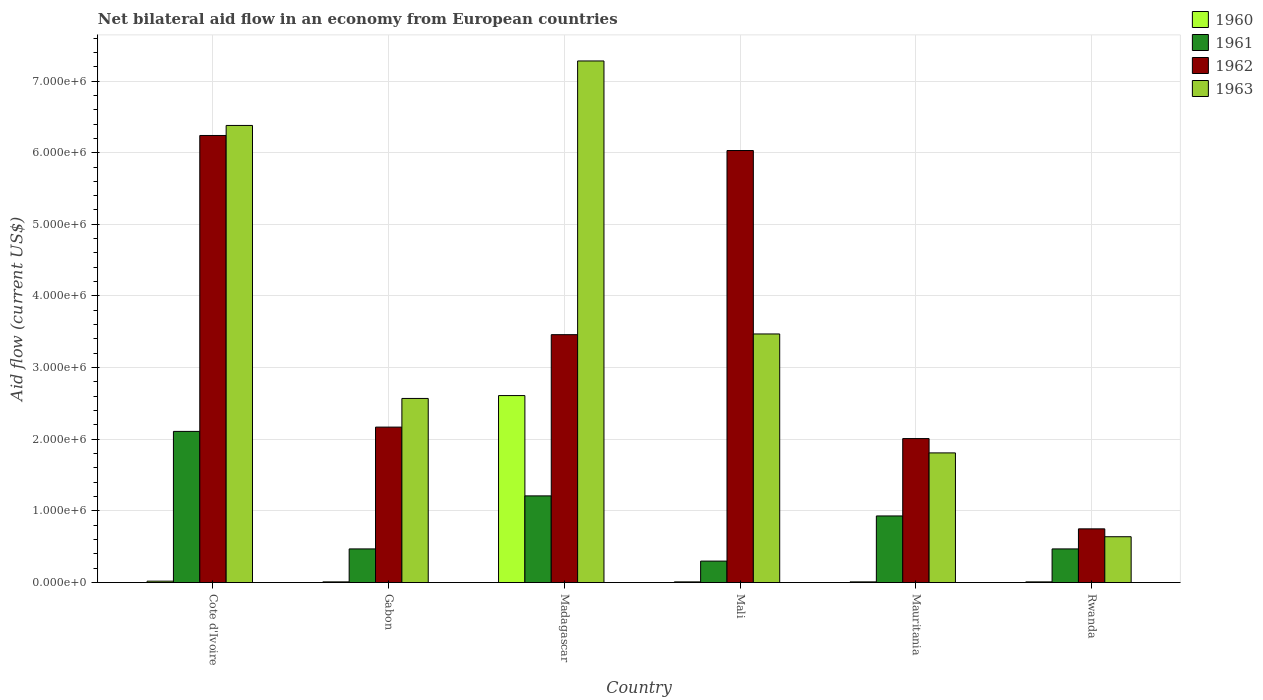How many different coloured bars are there?
Give a very brief answer. 4. Are the number of bars on each tick of the X-axis equal?
Provide a short and direct response. Yes. How many bars are there on the 4th tick from the left?
Provide a succinct answer. 4. How many bars are there on the 5th tick from the right?
Make the answer very short. 4. What is the label of the 2nd group of bars from the left?
Provide a succinct answer. Gabon. What is the net bilateral aid flow in 1960 in Rwanda?
Your answer should be compact. 10000. Across all countries, what is the maximum net bilateral aid flow in 1962?
Keep it short and to the point. 6.24e+06. Across all countries, what is the minimum net bilateral aid flow in 1963?
Your answer should be very brief. 6.40e+05. In which country was the net bilateral aid flow in 1963 maximum?
Give a very brief answer. Madagascar. In which country was the net bilateral aid flow in 1962 minimum?
Make the answer very short. Rwanda. What is the total net bilateral aid flow in 1960 in the graph?
Your answer should be compact. 2.67e+06. What is the difference between the net bilateral aid flow in 1962 in Cote d'Ivoire and that in Mauritania?
Ensure brevity in your answer.  4.23e+06. What is the difference between the net bilateral aid flow in 1963 in Madagascar and the net bilateral aid flow in 1962 in Cote d'Ivoire?
Keep it short and to the point. 1.04e+06. What is the average net bilateral aid flow in 1961 per country?
Your response must be concise. 9.15e+05. What is the difference between the net bilateral aid flow of/in 1961 and net bilateral aid flow of/in 1963 in Gabon?
Your response must be concise. -2.10e+06. What is the difference between the highest and the second highest net bilateral aid flow in 1963?
Provide a short and direct response. 3.81e+06. What is the difference between the highest and the lowest net bilateral aid flow in 1961?
Your answer should be compact. 1.81e+06. What does the 1st bar from the left in Rwanda represents?
Keep it short and to the point. 1960. Is it the case that in every country, the sum of the net bilateral aid flow in 1960 and net bilateral aid flow in 1963 is greater than the net bilateral aid flow in 1962?
Your response must be concise. No. How many bars are there?
Your response must be concise. 24. How many countries are there in the graph?
Provide a succinct answer. 6. What is the difference between two consecutive major ticks on the Y-axis?
Ensure brevity in your answer.  1.00e+06. Does the graph contain any zero values?
Provide a succinct answer. No. Does the graph contain grids?
Keep it short and to the point. Yes. How many legend labels are there?
Your response must be concise. 4. What is the title of the graph?
Make the answer very short. Net bilateral aid flow in an economy from European countries. What is the label or title of the X-axis?
Your answer should be compact. Country. What is the label or title of the Y-axis?
Offer a very short reply. Aid flow (current US$). What is the Aid flow (current US$) of 1960 in Cote d'Ivoire?
Provide a short and direct response. 2.00e+04. What is the Aid flow (current US$) in 1961 in Cote d'Ivoire?
Your answer should be compact. 2.11e+06. What is the Aid flow (current US$) of 1962 in Cote d'Ivoire?
Your answer should be compact. 6.24e+06. What is the Aid flow (current US$) in 1963 in Cote d'Ivoire?
Give a very brief answer. 6.38e+06. What is the Aid flow (current US$) in 1962 in Gabon?
Your answer should be very brief. 2.17e+06. What is the Aid flow (current US$) of 1963 in Gabon?
Make the answer very short. 2.57e+06. What is the Aid flow (current US$) in 1960 in Madagascar?
Offer a very short reply. 2.61e+06. What is the Aid flow (current US$) in 1961 in Madagascar?
Your answer should be compact. 1.21e+06. What is the Aid flow (current US$) of 1962 in Madagascar?
Make the answer very short. 3.46e+06. What is the Aid flow (current US$) of 1963 in Madagascar?
Provide a succinct answer. 7.28e+06. What is the Aid flow (current US$) of 1962 in Mali?
Keep it short and to the point. 6.03e+06. What is the Aid flow (current US$) in 1963 in Mali?
Provide a succinct answer. 3.47e+06. What is the Aid flow (current US$) in 1961 in Mauritania?
Your answer should be compact. 9.30e+05. What is the Aid flow (current US$) of 1962 in Mauritania?
Your answer should be compact. 2.01e+06. What is the Aid flow (current US$) in 1963 in Mauritania?
Offer a terse response. 1.81e+06. What is the Aid flow (current US$) in 1960 in Rwanda?
Your answer should be very brief. 10000. What is the Aid flow (current US$) of 1962 in Rwanda?
Your answer should be very brief. 7.50e+05. What is the Aid flow (current US$) of 1963 in Rwanda?
Your answer should be very brief. 6.40e+05. Across all countries, what is the maximum Aid flow (current US$) of 1960?
Provide a short and direct response. 2.61e+06. Across all countries, what is the maximum Aid flow (current US$) in 1961?
Ensure brevity in your answer.  2.11e+06. Across all countries, what is the maximum Aid flow (current US$) of 1962?
Your response must be concise. 6.24e+06. Across all countries, what is the maximum Aid flow (current US$) of 1963?
Your response must be concise. 7.28e+06. Across all countries, what is the minimum Aid flow (current US$) in 1960?
Offer a terse response. 10000. Across all countries, what is the minimum Aid flow (current US$) in 1961?
Give a very brief answer. 3.00e+05. Across all countries, what is the minimum Aid flow (current US$) of 1962?
Make the answer very short. 7.50e+05. Across all countries, what is the minimum Aid flow (current US$) of 1963?
Your response must be concise. 6.40e+05. What is the total Aid flow (current US$) of 1960 in the graph?
Your answer should be very brief. 2.67e+06. What is the total Aid flow (current US$) of 1961 in the graph?
Your answer should be very brief. 5.49e+06. What is the total Aid flow (current US$) in 1962 in the graph?
Keep it short and to the point. 2.07e+07. What is the total Aid flow (current US$) of 1963 in the graph?
Provide a succinct answer. 2.22e+07. What is the difference between the Aid flow (current US$) in 1961 in Cote d'Ivoire and that in Gabon?
Give a very brief answer. 1.64e+06. What is the difference between the Aid flow (current US$) in 1962 in Cote d'Ivoire and that in Gabon?
Provide a short and direct response. 4.07e+06. What is the difference between the Aid flow (current US$) of 1963 in Cote d'Ivoire and that in Gabon?
Offer a terse response. 3.81e+06. What is the difference between the Aid flow (current US$) of 1960 in Cote d'Ivoire and that in Madagascar?
Give a very brief answer. -2.59e+06. What is the difference between the Aid flow (current US$) in 1962 in Cote d'Ivoire and that in Madagascar?
Provide a short and direct response. 2.78e+06. What is the difference between the Aid flow (current US$) in 1963 in Cote d'Ivoire and that in Madagascar?
Keep it short and to the point. -9.00e+05. What is the difference between the Aid flow (current US$) of 1961 in Cote d'Ivoire and that in Mali?
Your answer should be very brief. 1.81e+06. What is the difference between the Aid flow (current US$) in 1962 in Cote d'Ivoire and that in Mali?
Keep it short and to the point. 2.10e+05. What is the difference between the Aid flow (current US$) in 1963 in Cote d'Ivoire and that in Mali?
Keep it short and to the point. 2.91e+06. What is the difference between the Aid flow (current US$) of 1960 in Cote d'Ivoire and that in Mauritania?
Ensure brevity in your answer.  10000. What is the difference between the Aid flow (current US$) of 1961 in Cote d'Ivoire and that in Mauritania?
Give a very brief answer. 1.18e+06. What is the difference between the Aid flow (current US$) in 1962 in Cote d'Ivoire and that in Mauritania?
Provide a succinct answer. 4.23e+06. What is the difference between the Aid flow (current US$) in 1963 in Cote d'Ivoire and that in Mauritania?
Make the answer very short. 4.57e+06. What is the difference between the Aid flow (current US$) in 1961 in Cote d'Ivoire and that in Rwanda?
Offer a very short reply. 1.64e+06. What is the difference between the Aid flow (current US$) in 1962 in Cote d'Ivoire and that in Rwanda?
Your answer should be compact. 5.49e+06. What is the difference between the Aid flow (current US$) of 1963 in Cote d'Ivoire and that in Rwanda?
Provide a succinct answer. 5.74e+06. What is the difference between the Aid flow (current US$) in 1960 in Gabon and that in Madagascar?
Your response must be concise. -2.60e+06. What is the difference between the Aid flow (current US$) in 1961 in Gabon and that in Madagascar?
Offer a very short reply. -7.40e+05. What is the difference between the Aid flow (current US$) of 1962 in Gabon and that in Madagascar?
Give a very brief answer. -1.29e+06. What is the difference between the Aid flow (current US$) of 1963 in Gabon and that in Madagascar?
Your response must be concise. -4.71e+06. What is the difference between the Aid flow (current US$) in 1960 in Gabon and that in Mali?
Offer a terse response. 0. What is the difference between the Aid flow (current US$) in 1961 in Gabon and that in Mali?
Your answer should be very brief. 1.70e+05. What is the difference between the Aid flow (current US$) of 1962 in Gabon and that in Mali?
Provide a short and direct response. -3.86e+06. What is the difference between the Aid flow (current US$) in 1963 in Gabon and that in Mali?
Make the answer very short. -9.00e+05. What is the difference between the Aid flow (current US$) of 1961 in Gabon and that in Mauritania?
Ensure brevity in your answer.  -4.60e+05. What is the difference between the Aid flow (current US$) in 1962 in Gabon and that in Mauritania?
Provide a succinct answer. 1.60e+05. What is the difference between the Aid flow (current US$) of 1963 in Gabon and that in Mauritania?
Your answer should be compact. 7.60e+05. What is the difference between the Aid flow (current US$) in 1962 in Gabon and that in Rwanda?
Your answer should be compact. 1.42e+06. What is the difference between the Aid flow (current US$) of 1963 in Gabon and that in Rwanda?
Give a very brief answer. 1.93e+06. What is the difference between the Aid flow (current US$) in 1960 in Madagascar and that in Mali?
Your answer should be compact. 2.60e+06. What is the difference between the Aid flow (current US$) of 1961 in Madagascar and that in Mali?
Give a very brief answer. 9.10e+05. What is the difference between the Aid flow (current US$) of 1962 in Madagascar and that in Mali?
Your response must be concise. -2.57e+06. What is the difference between the Aid flow (current US$) of 1963 in Madagascar and that in Mali?
Keep it short and to the point. 3.81e+06. What is the difference between the Aid flow (current US$) in 1960 in Madagascar and that in Mauritania?
Offer a very short reply. 2.60e+06. What is the difference between the Aid flow (current US$) in 1961 in Madagascar and that in Mauritania?
Your answer should be very brief. 2.80e+05. What is the difference between the Aid flow (current US$) of 1962 in Madagascar and that in Mauritania?
Offer a very short reply. 1.45e+06. What is the difference between the Aid flow (current US$) in 1963 in Madagascar and that in Mauritania?
Offer a very short reply. 5.47e+06. What is the difference between the Aid flow (current US$) of 1960 in Madagascar and that in Rwanda?
Make the answer very short. 2.60e+06. What is the difference between the Aid flow (current US$) in 1961 in Madagascar and that in Rwanda?
Offer a terse response. 7.40e+05. What is the difference between the Aid flow (current US$) of 1962 in Madagascar and that in Rwanda?
Your response must be concise. 2.71e+06. What is the difference between the Aid flow (current US$) in 1963 in Madagascar and that in Rwanda?
Keep it short and to the point. 6.64e+06. What is the difference between the Aid flow (current US$) of 1960 in Mali and that in Mauritania?
Keep it short and to the point. 0. What is the difference between the Aid flow (current US$) of 1961 in Mali and that in Mauritania?
Offer a terse response. -6.30e+05. What is the difference between the Aid flow (current US$) of 1962 in Mali and that in Mauritania?
Offer a terse response. 4.02e+06. What is the difference between the Aid flow (current US$) of 1963 in Mali and that in Mauritania?
Offer a very short reply. 1.66e+06. What is the difference between the Aid flow (current US$) in 1960 in Mali and that in Rwanda?
Ensure brevity in your answer.  0. What is the difference between the Aid flow (current US$) of 1962 in Mali and that in Rwanda?
Offer a terse response. 5.28e+06. What is the difference between the Aid flow (current US$) of 1963 in Mali and that in Rwanda?
Ensure brevity in your answer.  2.83e+06. What is the difference between the Aid flow (current US$) in 1960 in Mauritania and that in Rwanda?
Your answer should be very brief. 0. What is the difference between the Aid flow (current US$) of 1961 in Mauritania and that in Rwanda?
Give a very brief answer. 4.60e+05. What is the difference between the Aid flow (current US$) in 1962 in Mauritania and that in Rwanda?
Make the answer very short. 1.26e+06. What is the difference between the Aid flow (current US$) of 1963 in Mauritania and that in Rwanda?
Provide a short and direct response. 1.17e+06. What is the difference between the Aid flow (current US$) of 1960 in Cote d'Ivoire and the Aid flow (current US$) of 1961 in Gabon?
Your answer should be compact. -4.50e+05. What is the difference between the Aid flow (current US$) in 1960 in Cote d'Ivoire and the Aid flow (current US$) in 1962 in Gabon?
Offer a terse response. -2.15e+06. What is the difference between the Aid flow (current US$) of 1960 in Cote d'Ivoire and the Aid flow (current US$) of 1963 in Gabon?
Provide a succinct answer. -2.55e+06. What is the difference between the Aid flow (current US$) in 1961 in Cote d'Ivoire and the Aid flow (current US$) in 1962 in Gabon?
Offer a terse response. -6.00e+04. What is the difference between the Aid flow (current US$) of 1961 in Cote d'Ivoire and the Aid flow (current US$) of 1963 in Gabon?
Provide a succinct answer. -4.60e+05. What is the difference between the Aid flow (current US$) in 1962 in Cote d'Ivoire and the Aid flow (current US$) in 1963 in Gabon?
Your response must be concise. 3.67e+06. What is the difference between the Aid flow (current US$) of 1960 in Cote d'Ivoire and the Aid flow (current US$) of 1961 in Madagascar?
Provide a short and direct response. -1.19e+06. What is the difference between the Aid flow (current US$) of 1960 in Cote d'Ivoire and the Aid flow (current US$) of 1962 in Madagascar?
Provide a short and direct response. -3.44e+06. What is the difference between the Aid flow (current US$) of 1960 in Cote d'Ivoire and the Aid flow (current US$) of 1963 in Madagascar?
Offer a terse response. -7.26e+06. What is the difference between the Aid flow (current US$) of 1961 in Cote d'Ivoire and the Aid flow (current US$) of 1962 in Madagascar?
Offer a terse response. -1.35e+06. What is the difference between the Aid flow (current US$) in 1961 in Cote d'Ivoire and the Aid flow (current US$) in 1963 in Madagascar?
Provide a succinct answer. -5.17e+06. What is the difference between the Aid flow (current US$) in 1962 in Cote d'Ivoire and the Aid flow (current US$) in 1963 in Madagascar?
Offer a terse response. -1.04e+06. What is the difference between the Aid flow (current US$) of 1960 in Cote d'Ivoire and the Aid flow (current US$) of 1961 in Mali?
Offer a very short reply. -2.80e+05. What is the difference between the Aid flow (current US$) of 1960 in Cote d'Ivoire and the Aid flow (current US$) of 1962 in Mali?
Your response must be concise. -6.01e+06. What is the difference between the Aid flow (current US$) in 1960 in Cote d'Ivoire and the Aid flow (current US$) in 1963 in Mali?
Provide a succinct answer. -3.45e+06. What is the difference between the Aid flow (current US$) in 1961 in Cote d'Ivoire and the Aid flow (current US$) in 1962 in Mali?
Keep it short and to the point. -3.92e+06. What is the difference between the Aid flow (current US$) of 1961 in Cote d'Ivoire and the Aid flow (current US$) of 1963 in Mali?
Keep it short and to the point. -1.36e+06. What is the difference between the Aid flow (current US$) of 1962 in Cote d'Ivoire and the Aid flow (current US$) of 1963 in Mali?
Keep it short and to the point. 2.77e+06. What is the difference between the Aid flow (current US$) of 1960 in Cote d'Ivoire and the Aid flow (current US$) of 1961 in Mauritania?
Provide a succinct answer. -9.10e+05. What is the difference between the Aid flow (current US$) in 1960 in Cote d'Ivoire and the Aid flow (current US$) in 1962 in Mauritania?
Make the answer very short. -1.99e+06. What is the difference between the Aid flow (current US$) of 1960 in Cote d'Ivoire and the Aid flow (current US$) of 1963 in Mauritania?
Offer a very short reply. -1.79e+06. What is the difference between the Aid flow (current US$) of 1961 in Cote d'Ivoire and the Aid flow (current US$) of 1962 in Mauritania?
Ensure brevity in your answer.  1.00e+05. What is the difference between the Aid flow (current US$) in 1961 in Cote d'Ivoire and the Aid flow (current US$) in 1963 in Mauritania?
Make the answer very short. 3.00e+05. What is the difference between the Aid flow (current US$) in 1962 in Cote d'Ivoire and the Aid flow (current US$) in 1963 in Mauritania?
Offer a very short reply. 4.43e+06. What is the difference between the Aid flow (current US$) of 1960 in Cote d'Ivoire and the Aid flow (current US$) of 1961 in Rwanda?
Provide a short and direct response. -4.50e+05. What is the difference between the Aid flow (current US$) of 1960 in Cote d'Ivoire and the Aid flow (current US$) of 1962 in Rwanda?
Your answer should be very brief. -7.30e+05. What is the difference between the Aid flow (current US$) in 1960 in Cote d'Ivoire and the Aid flow (current US$) in 1963 in Rwanda?
Provide a succinct answer. -6.20e+05. What is the difference between the Aid flow (current US$) of 1961 in Cote d'Ivoire and the Aid flow (current US$) of 1962 in Rwanda?
Offer a terse response. 1.36e+06. What is the difference between the Aid flow (current US$) of 1961 in Cote d'Ivoire and the Aid flow (current US$) of 1963 in Rwanda?
Give a very brief answer. 1.47e+06. What is the difference between the Aid flow (current US$) of 1962 in Cote d'Ivoire and the Aid flow (current US$) of 1963 in Rwanda?
Offer a terse response. 5.60e+06. What is the difference between the Aid flow (current US$) of 1960 in Gabon and the Aid flow (current US$) of 1961 in Madagascar?
Your response must be concise. -1.20e+06. What is the difference between the Aid flow (current US$) in 1960 in Gabon and the Aid flow (current US$) in 1962 in Madagascar?
Keep it short and to the point. -3.45e+06. What is the difference between the Aid flow (current US$) in 1960 in Gabon and the Aid flow (current US$) in 1963 in Madagascar?
Ensure brevity in your answer.  -7.27e+06. What is the difference between the Aid flow (current US$) in 1961 in Gabon and the Aid flow (current US$) in 1962 in Madagascar?
Offer a very short reply. -2.99e+06. What is the difference between the Aid flow (current US$) in 1961 in Gabon and the Aid flow (current US$) in 1963 in Madagascar?
Offer a terse response. -6.81e+06. What is the difference between the Aid flow (current US$) in 1962 in Gabon and the Aid flow (current US$) in 1963 in Madagascar?
Your response must be concise. -5.11e+06. What is the difference between the Aid flow (current US$) in 1960 in Gabon and the Aid flow (current US$) in 1961 in Mali?
Offer a terse response. -2.90e+05. What is the difference between the Aid flow (current US$) of 1960 in Gabon and the Aid flow (current US$) of 1962 in Mali?
Your answer should be compact. -6.02e+06. What is the difference between the Aid flow (current US$) in 1960 in Gabon and the Aid flow (current US$) in 1963 in Mali?
Provide a succinct answer. -3.46e+06. What is the difference between the Aid flow (current US$) of 1961 in Gabon and the Aid flow (current US$) of 1962 in Mali?
Your answer should be very brief. -5.56e+06. What is the difference between the Aid flow (current US$) in 1962 in Gabon and the Aid flow (current US$) in 1963 in Mali?
Give a very brief answer. -1.30e+06. What is the difference between the Aid flow (current US$) in 1960 in Gabon and the Aid flow (current US$) in 1961 in Mauritania?
Provide a short and direct response. -9.20e+05. What is the difference between the Aid flow (current US$) in 1960 in Gabon and the Aid flow (current US$) in 1962 in Mauritania?
Keep it short and to the point. -2.00e+06. What is the difference between the Aid flow (current US$) of 1960 in Gabon and the Aid flow (current US$) of 1963 in Mauritania?
Your response must be concise. -1.80e+06. What is the difference between the Aid flow (current US$) of 1961 in Gabon and the Aid flow (current US$) of 1962 in Mauritania?
Ensure brevity in your answer.  -1.54e+06. What is the difference between the Aid flow (current US$) in 1961 in Gabon and the Aid flow (current US$) in 1963 in Mauritania?
Offer a terse response. -1.34e+06. What is the difference between the Aid flow (current US$) of 1962 in Gabon and the Aid flow (current US$) of 1963 in Mauritania?
Your response must be concise. 3.60e+05. What is the difference between the Aid flow (current US$) of 1960 in Gabon and the Aid flow (current US$) of 1961 in Rwanda?
Keep it short and to the point. -4.60e+05. What is the difference between the Aid flow (current US$) of 1960 in Gabon and the Aid flow (current US$) of 1962 in Rwanda?
Ensure brevity in your answer.  -7.40e+05. What is the difference between the Aid flow (current US$) of 1960 in Gabon and the Aid flow (current US$) of 1963 in Rwanda?
Your response must be concise. -6.30e+05. What is the difference between the Aid flow (current US$) in 1961 in Gabon and the Aid flow (current US$) in 1962 in Rwanda?
Your answer should be compact. -2.80e+05. What is the difference between the Aid flow (current US$) in 1962 in Gabon and the Aid flow (current US$) in 1963 in Rwanda?
Your answer should be compact. 1.53e+06. What is the difference between the Aid flow (current US$) of 1960 in Madagascar and the Aid flow (current US$) of 1961 in Mali?
Ensure brevity in your answer.  2.31e+06. What is the difference between the Aid flow (current US$) in 1960 in Madagascar and the Aid flow (current US$) in 1962 in Mali?
Provide a succinct answer. -3.42e+06. What is the difference between the Aid flow (current US$) of 1960 in Madagascar and the Aid flow (current US$) of 1963 in Mali?
Give a very brief answer. -8.60e+05. What is the difference between the Aid flow (current US$) of 1961 in Madagascar and the Aid flow (current US$) of 1962 in Mali?
Make the answer very short. -4.82e+06. What is the difference between the Aid flow (current US$) in 1961 in Madagascar and the Aid flow (current US$) in 1963 in Mali?
Make the answer very short. -2.26e+06. What is the difference between the Aid flow (current US$) in 1962 in Madagascar and the Aid flow (current US$) in 1963 in Mali?
Your response must be concise. -10000. What is the difference between the Aid flow (current US$) in 1960 in Madagascar and the Aid flow (current US$) in 1961 in Mauritania?
Provide a short and direct response. 1.68e+06. What is the difference between the Aid flow (current US$) in 1961 in Madagascar and the Aid flow (current US$) in 1962 in Mauritania?
Offer a very short reply. -8.00e+05. What is the difference between the Aid flow (current US$) of 1961 in Madagascar and the Aid flow (current US$) of 1963 in Mauritania?
Offer a very short reply. -6.00e+05. What is the difference between the Aid flow (current US$) of 1962 in Madagascar and the Aid flow (current US$) of 1963 in Mauritania?
Make the answer very short. 1.65e+06. What is the difference between the Aid flow (current US$) in 1960 in Madagascar and the Aid flow (current US$) in 1961 in Rwanda?
Provide a succinct answer. 2.14e+06. What is the difference between the Aid flow (current US$) of 1960 in Madagascar and the Aid flow (current US$) of 1962 in Rwanda?
Provide a short and direct response. 1.86e+06. What is the difference between the Aid flow (current US$) of 1960 in Madagascar and the Aid flow (current US$) of 1963 in Rwanda?
Offer a terse response. 1.97e+06. What is the difference between the Aid flow (current US$) of 1961 in Madagascar and the Aid flow (current US$) of 1963 in Rwanda?
Ensure brevity in your answer.  5.70e+05. What is the difference between the Aid flow (current US$) of 1962 in Madagascar and the Aid flow (current US$) of 1963 in Rwanda?
Your answer should be compact. 2.82e+06. What is the difference between the Aid flow (current US$) of 1960 in Mali and the Aid flow (current US$) of 1961 in Mauritania?
Keep it short and to the point. -9.20e+05. What is the difference between the Aid flow (current US$) in 1960 in Mali and the Aid flow (current US$) in 1962 in Mauritania?
Provide a short and direct response. -2.00e+06. What is the difference between the Aid flow (current US$) in 1960 in Mali and the Aid flow (current US$) in 1963 in Mauritania?
Offer a very short reply. -1.80e+06. What is the difference between the Aid flow (current US$) in 1961 in Mali and the Aid flow (current US$) in 1962 in Mauritania?
Provide a short and direct response. -1.71e+06. What is the difference between the Aid flow (current US$) of 1961 in Mali and the Aid flow (current US$) of 1963 in Mauritania?
Provide a short and direct response. -1.51e+06. What is the difference between the Aid flow (current US$) in 1962 in Mali and the Aid flow (current US$) in 1963 in Mauritania?
Offer a terse response. 4.22e+06. What is the difference between the Aid flow (current US$) in 1960 in Mali and the Aid flow (current US$) in 1961 in Rwanda?
Provide a succinct answer. -4.60e+05. What is the difference between the Aid flow (current US$) of 1960 in Mali and the Aid flow (current US$) of 1962 in Rwanda?
Keep it short and to the point. -7.40e+05. What is the difference between the Aid flow (current US$) of 1960 in Mali and the Aid flow (current US$) of 1963 in Rwanda?
Ensure brevity in your answer.  -6.30e+05. What is the difference between the Aid flow (current US$) of 1961 in Mali and the Aid flow (current US$) of 1962 in Rwanda?
Ensure brevity in your answer.  -4.50e+05. What is the difference between the Aid flow (current US$) in 1961 in Mali and the Aid flow (current US$) in 1963 in Rwanda?
Your answer should be very brief. -3.40e+05. What is the difference between the Aid flow (current US$) of 1962 in Mali and the Aid flow (current US$) of 1963 in Rwanda?
Your response must be concise. 5.39e+06. What is the difference between the Aid flow (current US$) in 1960 in Mauritania and the Aid flow (current US$) in 1961 in Rwanda?
Provide a succinct answer. -4.60e+05. What is the difference between the Aid flow (current US$) in 1960 in Mauritania and the Aid flow (current US$) in 1962 in Rwanda?
Keep it short and to the point. -7.40e+05. What is the difference between the Aid flow (current US$) of 1960 in Mauritania and the Aid flow (current US$) of 1963 in Rwanda?
Make the answer very short. -6.30e+05. What is the difference between the Aid flow (current US$) of 1962 in Mauritania and the Aid flow (current US$) of 1963 in Rwanda?
Your answer should be very brief. 1.37e+06. What is the average Aid flow (current US$) of 1960 per country?
Give a very brief answer. 4.45e+05. What is the average Aid flow (current US$) of 1961 per country?
Your answer should be very brief. 9.15e+05. What is the average Aid flow (current US$) in 1962 per country?
Your answer should be very brief. 3.44e+06. What is the average Aid flow (current US$) of 1963 per country?
Your response must be concise. 3.69e+06. What is the difference between the Aid flow (current US$) in 1960 and Aid flow (current US$) in 1961 in Cote d'Ivoire?
Give a very brief answer. -2.09e+06. What is the difference between the Aid flow (current US$) in 1960 and Aid flow (current US$) in 1962 in Cote d'Ivoire?
Keep it short and to the point. -6.22e+06. What is the difference between the Aid flow (current US$) in 1960 and Aid flow (current US$) in 1963 in Cote d'Ivoire?
Your response must be concise. -6.36e+06. What is the difference between the Aid flow (current US$) of 1961 and Aid flow (current US$) of 1962 in Cote d'Ivoire?
Your answer should be compact. -4.13e+06. What is the difference between the Aid flow (current US$) of 1961 and Aid flow (current US$) of 1963 in Cote d'Ivoire?
Provide a short and direct response. -4.27e+06. What is the difference between the Aid flow (current US$) of 1962 and Aid flow (current US$) of 1963 in Cote d'Ivoire?
Offer a very short reply. -1.40e+05. What is the difference between the Aid flow (current US$) of 1960 and Aid flow (current US$) of 1961 in Gabon?
Make the answer very short. -4.60e+05. What is the difference between the Aid flow (current US$) of 1960 and Aid flow (current US$) of 1962 in Gabon?
Provide a succinct answer. -2.16e+06. What is the difference between the Aid flow (current US$) in 1960 and Aid flow (current US$) in 1963 in Gabon?
Ensure brevity in your answer.  -2.56e+06. What is the difference between the Aid flow (current US$) in 1961 and Aid flow (current US$) in 1962 in Gabon?
Keep it short and to the point. -1.70e+06. What is the difference between the Aid flow (current US$) in 1961 and Aid flow (current US$) in 1963 in Gabon?
Your answer should be compact. -2.10e+06. What is the difference between the Aid flow (current US$) in 1962 and Aid flow (current US$) in 1963 in Gabon?
Give a very brief answer. -4.00e+05. What is the difference between the Aid flow (current US$) of 1960 and Aid flow (current US$) of 1961 in Madagascar?
Ensure brevity in your answer.  1.40e+06. What is the difference between the Aid flow (current US$) of 1960 and Aid flow (current US$) of 1962 in Madagascar?
Your response must be concise. -8.50e+05. What is the difference between the Aid flow (current US$) in 1960 and Aid flow (current US$) in 1963 in Madagascar?
Keep it short and to the point. -4.67e+06. What is the difference between the Aid flow (current US$) in 1961 and Aid flow (current US$) in 1962 in Madagascar?
Give a very brief answer. -2.25e+06. What is the difference between the Aid flow (current US$) of 1961 and Aid flow (current US$) of 1963 in Madagascar?
Your answer should be very brief. -6.07e+06. What is the difference between the Aid flow (current US$) in 1962 and Aid flow (current US$) in 1963 in Madagascar?
Make the answer very short. -3.82e+06. What is the difference between the Aid flow (current US$) in 1960 and Aid flow (current US$) in 1962 in Mali?
Your response must be concise. -6.02e+06. What is the difference between the Aid flow (current US$) in 1960 and Aid flow (current US$) in 1963 in Mali?
Provide a short and direct response. -3.46e+06. What is the difference between the Aid flow (current US$) of 1961 and Aid flow (current US$) of 1962 in Mali?
Your answer should be very brief. -5.73e+06. What is the difference between the Aid flow (current US$) in 1961 and Aid flow (current US$) in 1963 in Mali?
Offer a very short reply. -3.17e+06. What is the difference between the Aid flow (current US$) in 1962 and Aid flow (current US$) in 1963 in Mali?
Keep it short and to the point. 2.56e+06. What is the difference between the Aid flow (current US$) in 1960 and Aid flow (current US$) in 1961 in Mauritania?
Your response must be concise. -9.20e+05. What is the difference between the Aid flow (current US$) in 1960 and Aid flow (current US$) in 1963 in Mauritania?
Your answer should be compact. -1.80e+06. What is the difference between the Aid flow (current US$) of 1961 and Aid flow (current US$) of 1962 in Mauritania?
Provide a short and direct response. -1.08e+06. What is the difference between the Aid flow (current US$) of 1961 and Aid flow (current US$) of 1963 in Mauritania?
Keep it short and to the point. -8.80e+05. What is the difference between the Aid flow (current US$) in 1960 and Aid flow (current US$) in 1961 in Rwanda?
Give a very brief answer. -4.60e+05. What is the difference between the Aid flow (current US$) of 1960 and Aid flow (current US$) of 1962 in Rwanda?
Provide a succinct answer. -7.40e+05. What is the difference between the Aid flow (current US$) of 1960 and Aid flow (current US$) of 1963 in Rwanda?
Ensure brevity in your answer.  -6.30e+05. What is the difference between the Aid flow (current US$) of 1961 and Aid flow (current US$) of 1962 in Rwanda?
Your response must be concise. -2.80e+05. What is the difference between the Aid flow (current US$) of 1962 and Aid flow (current US$) of 1963 in Rwanda?
Your answer should be compact. 1.10e+05. What is the ratio of the Aid flow (current US$) of 1960 in Cote d'Ivoire to that in Gabon?
Your response must be concise. 2. What is the ratio of the Aid flow (current US$) of 1961 in Cote d'Ivoire to that in Gabon?
Your answer should be compact. 4.49. What is the ratio of the Aid flow (current US$) in 1962 in Cote d'Ivoire to that in Gabon?
Your response must be concise. 2.88. What is the ratio of the Aid flow (current US$) of 1963 in Cote d'Ivoire to that in Gabon?
Provide a succinct answer. 2.48. What is the ratio of the Aid flow (current US$) in 1960 in Cote d'Ivoire to that in Madagascar?
Your response must be concise. 0.01. What is the ratio of the Aid flow (current US$) in 1961 in Cote d'Ivoire to that in Madagascar?
Provide a short and direct response. 1.74. What is the ratio of the Aid flow (current US$) of 1962 in Cote d'Ivoire to that in Madagascar?
Ensure brevity in your answer.  1.8. What is the ratio of the Aid flow (current US$) of 1963 in Cote d'Ivoire to that in Madagascar?
Your answer should be compact. 0.88. What is the ratio of the Aid flow (current US$) in 1961 in Cote d'Ivoire to that in Mali?
Give a very brief answer. 7.03. What is the ratio of the Aid flow (current US$) of 1962 in Cote d'Ivoire to that in Mali?
Keep it short and to the point. 1.03. What is the ratio of the Aid flow (current US$) of 1963 in Cote d'Ivoire to that in Mali?
Your answer should be very brief. 1.84. What is the ratio of the Aid flow (current US$) in 1961 in Cote d'Ivoire to that in Mauritania?
Keep it short and to the point. 2.27. What is the ratio of the Aid flow (current US$) in 1962 in Cote d'Ivoire to that in Mauritania?
Your response must be concise. 3.1. What is the ratio of the Aid flow (current US$) in 1963 in Cote d'Ivoire to that in Mauritania?
Your answer should be very brief. 3.52. What is the ratio of the Aid flow (current US$) of 1960 in Cote d'Ivoire to that in Rwanda?
Provide a succinct answer. 2. What is the ratio of the Aid flow (current US$) of 1961 in Cote d'Ivoire to that in Rwanda?
Your response must be concise. 4.49. What is the ratio of the Aid flow (current US$) of 1962 in Cote d'Ivoire to that in Rwanda?
Provide a succinct answer. 8.32. What is the ratio of the Aid flow (current US$) in 1963 in Cote d'Ivoire to that in Rwanda?
Your answer should be very brief. 9.97. What is the ratio of the Aid flow (current US$) of 1960 in Gabon to that in Madagascar?
Your response must be concise. 0. What is the ratio of the Aid flow (current US$) of 1961 in Gabon to that in Madagascar?
Provide a succinct answer. 0.39. What is the ratio of the Aid flow (current US$) of 1962 in Gabon to that in Madagascar?
Provide a succinct answer. 0.63. What is the ratio of the Aid flow (current US$) of 1963 in Gabon to that in Madagascar?
Offer a very short reply. 0.35. What is the ratio of the Aid flow (current US$) of 1961 in Gabon to that in Mali?
Your answer should be compact. 1.57. What is the ratio of the Aid flow (current US$) in 1962 in Gabon to that in Mali?
Provide a short and direct response. 0.36. What is the ratio of the Aid flow (current US$) in 1963 in Gabon to that in Mali?
Provide a succinct answer. 0.74. What is the ratio of the Aid flow (current US$) of 1960 in Gabon to that in Mauritania?
Provide a short and direct response. 1. What is the ratio of the Aid flow (current US$) of 1961 in Gabon to that in Mauritania?
Give a very brief answer. 0.51. What is the ratio of the Aid flow (current US$) in 1962 in Gabon to that in Mauritania?
Offer a very short reply. 1.08. What is the ratio of the Aid flow (current US$) in 1963 in Gabon to that in Mauritania?
Ensure brevity in your answer.  1.42. What is the ratio of the Aid flow (current US$) of 1961 in Gabon to that in Rwanda?
Your response must be concise. 1. What is the ratio of the Aid flow (current US$) of 1962 in Gabon to that in Rwanda?
Offer a very short reply. 2.89. What is the ratio of the Aid flow (current US$) of 1963 in Gabon to that in Rwanda?
Provide a succinct answer. 4.02. What is the ratio of the Aid flow (current US$) in 1960 in Madagascar to that in Mali?
Your response must be concise. 261. What is the ratio of the Aid flow (current US$) of 1961 in Madagascar to that in Mali?
Keep it short and to the point. 4.03. What is the ratio of the Aid flow (current US$) in 1962 in Madagascar to that in Mali?
Make the answer very short. 0.57. What is the ratio of the Aid flow (current US$) of 1963 in Madagascar to that in Mali?
Ensure brevity in your answer.  2.1. What is the ratio of the Aid flow (current US$) in 1960 in Madagascar to that in Mauritania?
Offer a terse response. 261. What is the ratio of the Aid flow (current US$) in 1961 in Madagascar to that in Mauritania?
Make the answer very short. 1.3. What is the ratio of the Aid flow (current US$) of 1962 in Madagascar to that in Mauritania?
Keep it short and to the point. 1.72. What is the ratio of the Aid flow (current US$) of 1963 in Madagascar to that in Mauritania?
Offer a terse response. 4.02. What is the ratio of the Aid flow (current US$) in 1960 in Madagascar to that in Rwanda?
Your answer should be very brief. 261. What is the ratio of the Aid flow (current US$) of 1961 in Madagascar to that in Rwanda?
Keep it short and to the point. 2.57. What is the ratio of the Aid flow (current US$) in 1962 in Madagascar to that in Rwanda?
Your response must be concise. 4.61. What is the ratio of the Aid flow (current US$) of 1963 in Madagascar to that in Rwanda?
Offer a very short reply. 11.38. What is the ratio of the Aid flow (current US$) of 1961 in Mali to that in Mauritania?
Keep it short and to the point. 0.32. What is the ratio of the Aid flow (current US$) of 1962 in Mali to that in Mauritania?
Your answer should be very brief. 3. What is the ratio of the Aid flow (current US$) of 1963 in Mali to that in Mauritania?
Your answer should be very brief. 1.92. What is the ratio of the Aid flow (current US$) of 1960 in Mali to that in Rwanda?
Keep it short and to the point. 1. What is the ratio of the Aid flow (current US$) of 1961 in Mali to that in Rwanda?
Your answer should be compact. 0.64. What is the ratio of the Aid flow (current US$) in 1962 in Mali to that in Rwanda?
Your answer should be very brief. 8.04. What is the ratio of the Aid flow (current US$) in 1963 in Mali to that in Rwanda?
Provide a short and direct response. 5.42. What is the ratio of the Aid flow (current US$) in 1960 in Mauritania to that in Rwanda?
Your answer should be very brief. 1. What is the ratio of the Aid flow (current US$) of 1961 in Mauritania to that in Rwanda?
Make the answer very short. 1.98. What is the ratio of the Aid flow (current US$) of 1962 in Mauritania to that in Rwanda?
Offer a terse response. 2.68. What is the ratio of the Aid flow (current US$) of 1963 in Mauritania to that in Rwanda?
Your answer should be compact. 2.83. What is the difference between the highest and the second highest Aid flow (current US$) in 1960?
Your answer should be compact. 2.59e+06. What is the difference between the highest and the second highest Aid flow (current US$) in 1961?
Give a very brief answer. 9.00e+05. What is the difference between the highest and the second highest Aid flow (current US$) in 1963?
Provide a short and direct response. 9.00e+05. What is the difference between the highest and the lowest Aid flow (current US$) of 1960?
Provide a short and direct response. 2.60e+06. What is the difference between the highest and the lowest Aid flow (current US$) of 1961?
Your response must be concise. 1.81e+06. What is the difference between the highest and the lowest Aid flow (current US$) of 1962?
Offer a very short reply. 5.49e+06. What is the difference between the highest and the lowest Aid flow (current US$) of 1963?
Your response must be concise. 6.64e+06. 